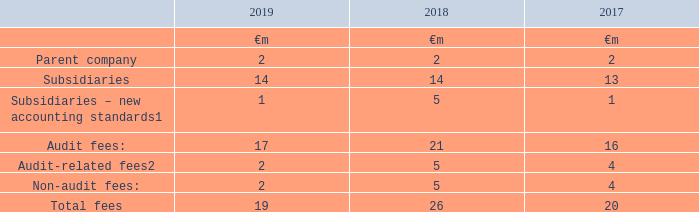The total remuneration of the Group’s auditors, PricewaterhouseCoopers LLP and other member firms of PricewaterhouseCoopers International Limited, for services provided to the Group during the year ended 31 March 2019 is analysed below
Notes: 1 Fees during the implementation phase of new accounting standards, notably preparations for IFRS 15 “Revenue from Contracts with Customers” in the year ended 31 March 2018 and preparations for IFRS 16 “Leases” in the year ended 31 March 2019.
2 Relates to fees for statutory and regulatory filings during the year. In addition, the amount for the year ended 31 March 2018 includes non-recurring fees that were incurred during the preparations for a potential IPO of Vodafone New Zealand and the merger of Vodafone India and Idea Cellular. The amount for the year ended 31 March 2017 primarily arose from work on regulatory filings prepared in anticipation of a potential IPO of Vodafone India that was under consideration prior to the agreement for the merger of Vodafone India and Idea Cellular.
A description of the work performed by the Audit and Risk Committee in order to safeguard auditor independence when non-audit services are provided is set out in the Audit and Risk Committee report on pages 71 to 76.
Which financial years' information is shown in the table? 2017, 2018, 2019. What information does the table show? The total remuneration of the group’s auditors, pricewaterhousecoopers llp and other member firms of pricewaterhousecoopers international limited, for services provided to the group during the year ended 31 march 2019. How much is the 2019 audit fees ?
Answer scale should be: million. 17. What is the average audit fees for 2018 and 2019?
Answer scale should be: million. (17+21)/2
Answer: 19. What is the average total fees for 2018 and 2019?
Answer scale should be: million. (19+26)/2
Answer: 22.5. What is the difference between the average audit fees and the average total fees for 2018 and 2019?
Answer scale should be: million. [(17+21)/2] - [(19+26)/2]
Answer: -3.5. 